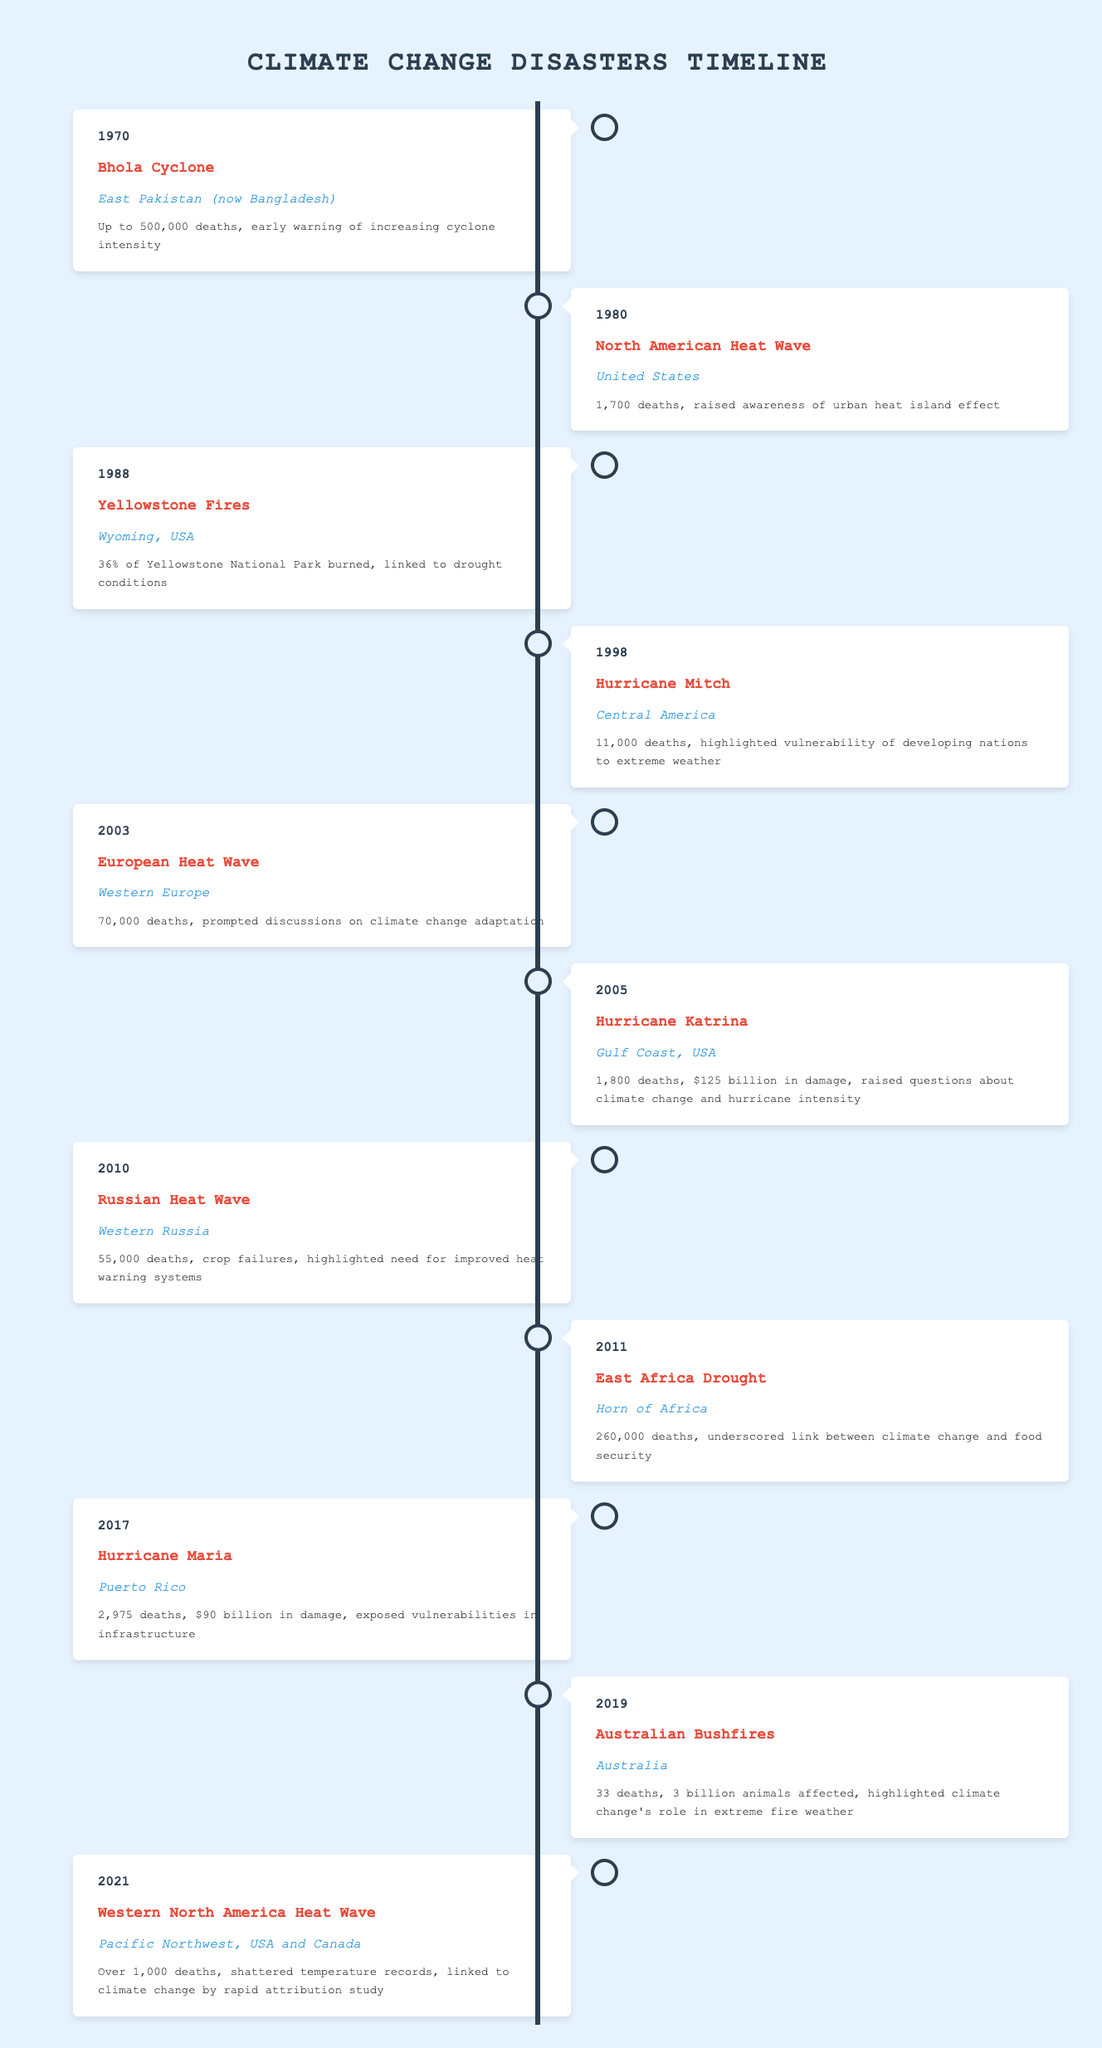What was the impact of Hurricane Katrina? The impact of Hurricane Katrina was listed as 1,800 deaths and $125 billion in damage, raising questions about climate change and hurricane intensity.
Answer: 1,800 deaths, $125 billion in damage Which event caused the most deaths? To find this, we can look at the impact figures in the table. The East Africa Drought in 2011 had the highest death toll of 260,000.
Answer: East Africa Drought in 2011 What is the average number of deaths from the disasters listed? First, sum the death tolls from the events: 500,000 + 1,700 + 36 + 11,000 + 70,000 + 1,800 + 55,000 + 260,000 + 2,975 + 33 + 1,000 = 903,508. There are 11 events listed, so the average is 903,508 / 11 ≈ 82,418.
Answer: Approximately 82,418 Did any disaster occur in the year 2005? Yes, Hurricane Katrina occurred in the year 2005, with its impacts documented in the table.
Answer: Yes Which natural disaster highlighted the vulnerability of developing nations? The event that specifically highlighted the vulnerability of developing nations was Hurricane Mitch in 1998, which resulted in 11,000 deaths.
Answer: Hurricane Mitch in 1998 What was the impact of the Australian Bushfires? The Australian Bushfires had an impact of 33 deaths and affected 3 billion animals, illustrating climate change's role in extreme fire weather.
Answer: 33 deaths, 3 billion animals affected Was there a heat wave event recorded in 2021? Yes, there was a heat wave in 2021 referred to as the Western North America Heat Wave, which had over 1,000 deaths.
Answer: Yes In which location did the Bhola Cyclone occur, and what was its impact? The Bhola Cyclone occurred in East Pakistan (now Bangladesh), resulting in up to 500,000 deaths and providing early warning of increasing cyclone intensity.
Answer: East Pakistan, up to 500,000 deaths 